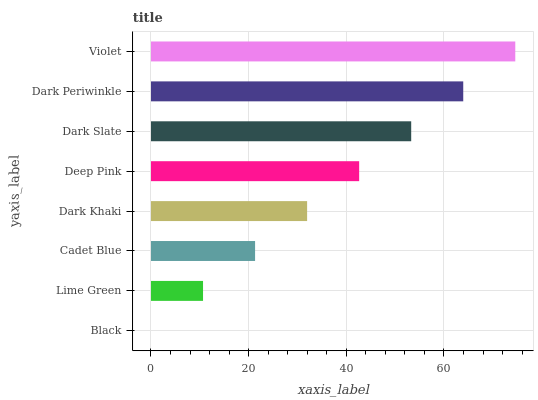Is Black the minimum?
Answer yes or no. Yes. Is Violet the maximum?
Answer yes or no. Yes. Is Lime Green the minimum?
Answer yes or no. No. Is Lime Green the maximum?
Answer yes or no. No. Is Lime Green greater than Black?
Answer yes or no. Yes. Is Black less than Lime Green?
Answer yes or no. Yes. Is Black greater than Lime Green?
Answer yes or no. No. Is Lime Green less than Black?
Answer yes or no. No. Is Deep Pink the high median?
Answer yes or no. Yes. Is Dark Khaki the low median?
Answer yes or no. Yes. Is Dark Khaki the high median?
Answer yes or no. No. Is Dark Periwinkle the low median?
Answer yes or no. No. 